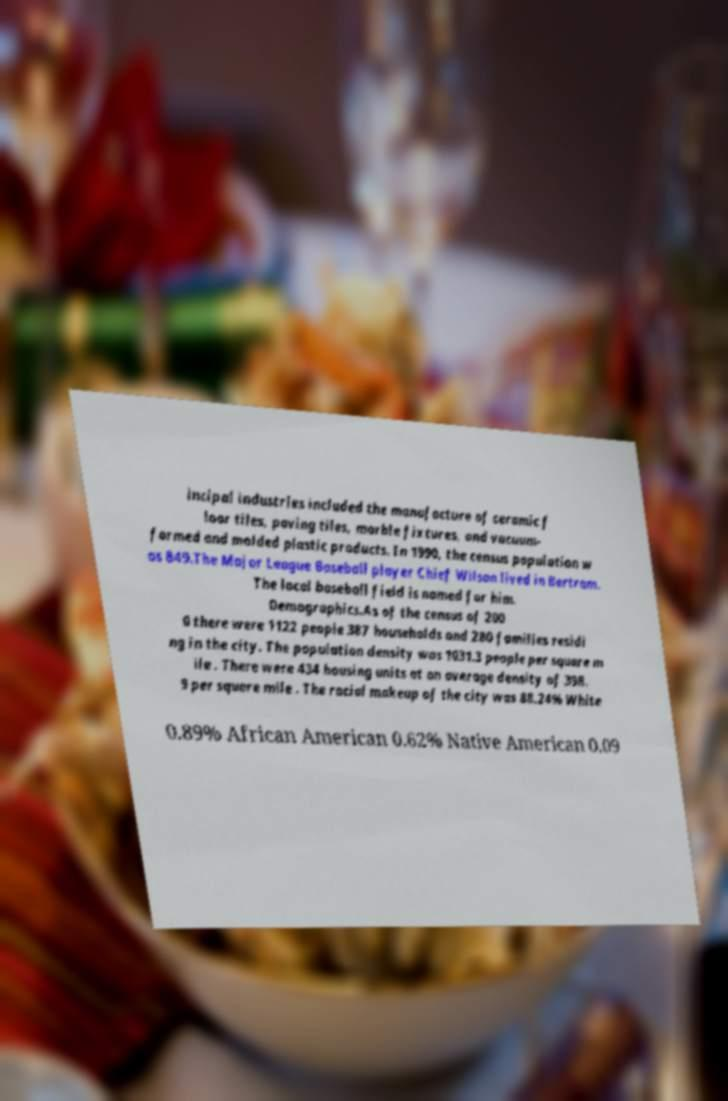For documentation purposes, I need the text within this image transcribed. Could you provide that? incipal industries included the manufacture of ceramic f loor tiles, paving tiles, marble fixtures, and vacuum- formed and molded plastic products. In 1990, the census population w as 849.The Major League Baseball player Chief Wilson lived in Bertram. The local baseball field is named for him. Demographics.As of the census of 200 0 there were 1122 people 387 households and 280 families residi ng in the city. The population density was 1031.3 people per square m ile . There were 434 housing units at an average density of 398. 9 per square mile . The racial makeup of the city was 88.24% White 0.89% African American 0.62% Native American 0.09 